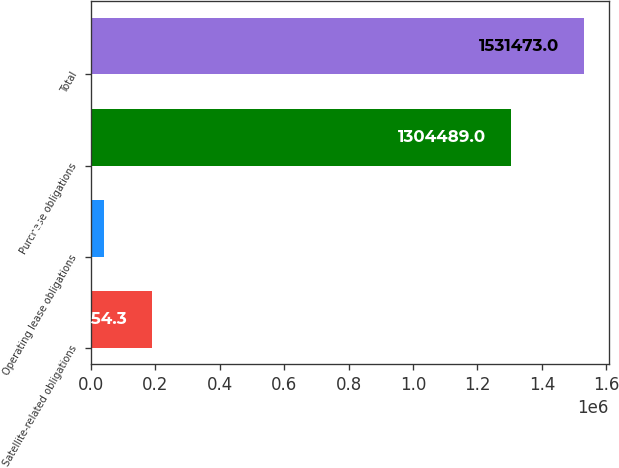<chart> <loc_0><loc_0><loc_500><loc_500><bar_chart><fcel>Satellite-related obligations<fcel>Operating lease obligations<fcel>Purchase obligations<fcel>Total<nl><fcel>191154<fcel>42230<fcel>1.30449e+06<fcel>1.53147e+06<nl></chart> 